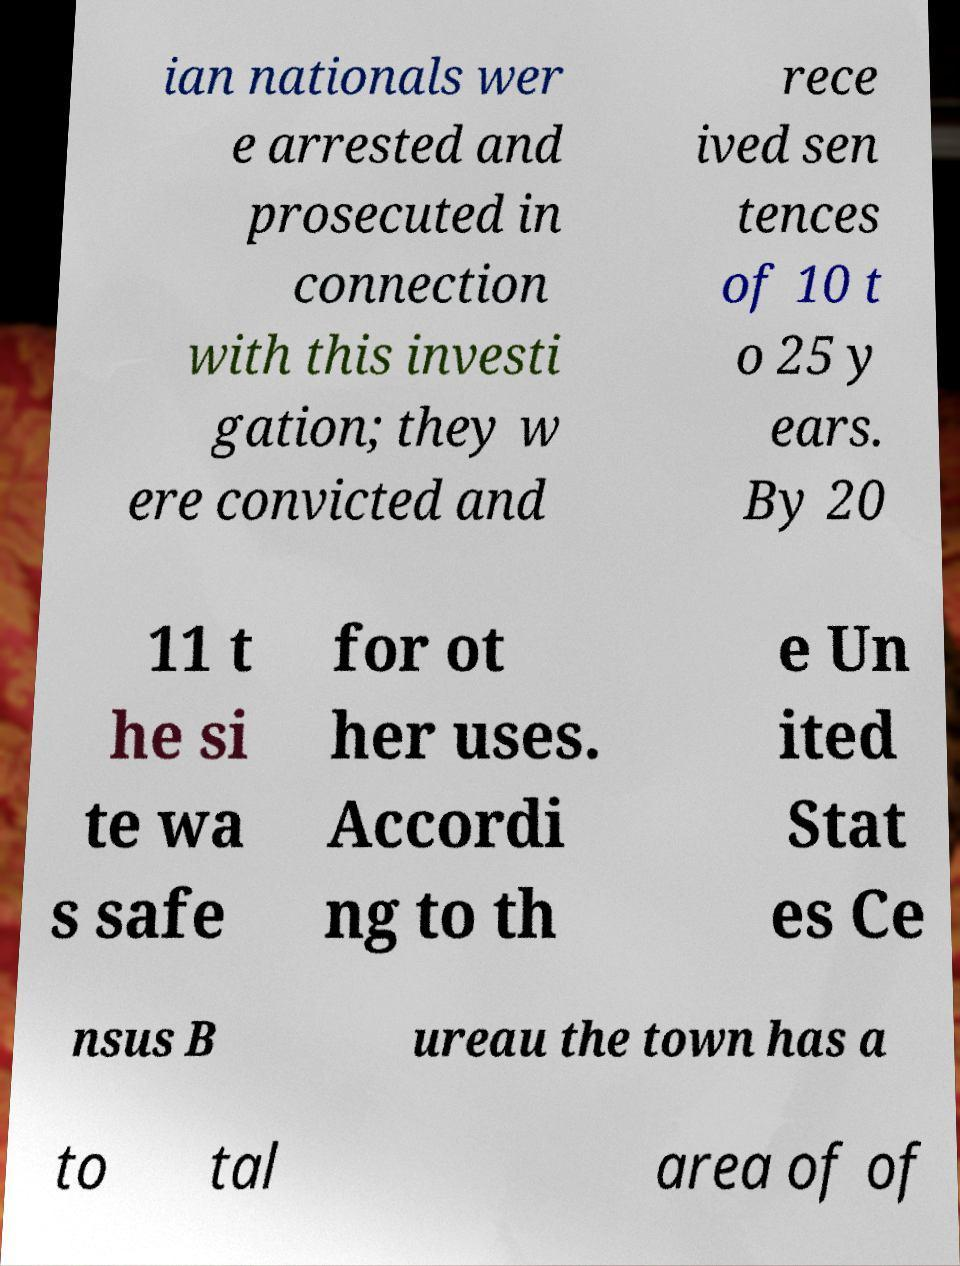There's text embedded in this image that I need extracted. Can you transcribe it verbatim? ian nationals wer e arrested and prosecuted in connection with this investi gation; they w ere convicted and rece ived sen tences of 10 t o 25 y ears. By 20 11 t he si te wa s safe for ot her uses. Accordi ng to th e Un ited Stat es Ce nsus B ureau the town has a to tal area of of 